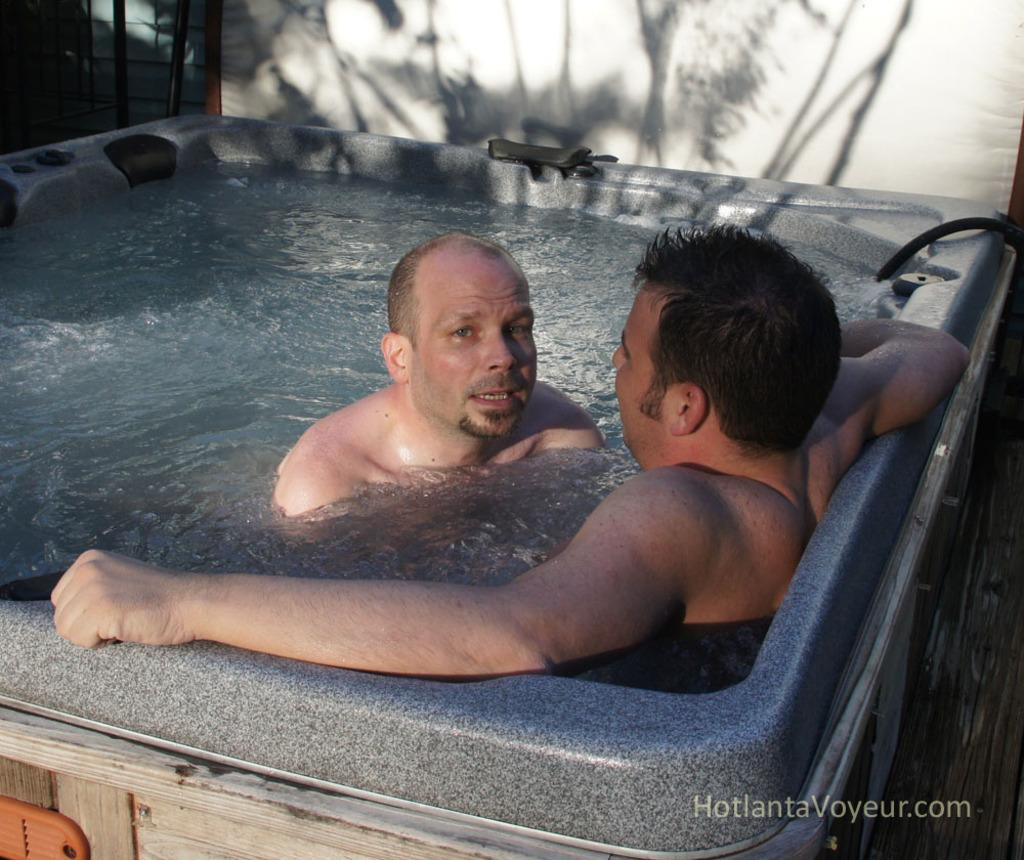How many people are in the water in the image? There are two people in the water in the image. What is one person doing in relation to the other person? One man is looking at the other person. What can be seen on the white wall in the image? There is a shadow of a tree on a white wall. What is present at the bottom of the image? There is a watermark at the bottom of the image. What hobbies do the people in the image have? There is no information about the hobbies of the people in the image. Can you provide a list of all the items present in the image? The provided facts only mention the two people in the water, one man looking at the other person, the shadow of a tree on a white wall, and the watermark at the bottom of the image. It is not possible to provide a comprehensive list of all items present in the image. 